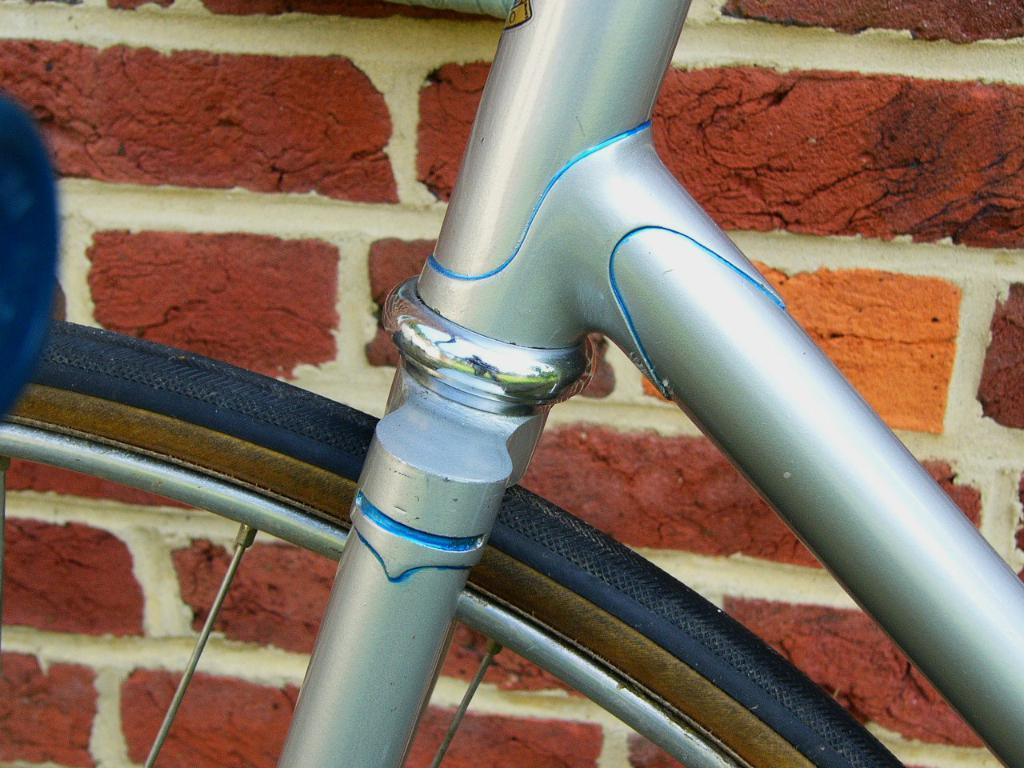What type of material is used for the rods in the image? The rods in the image are made of metal. What other object can be seen in the image besides the metal rods? There is a bicycle wheel in the image. What type of sail can be seen on the bicycle wheel in the image? There is no sail present on the bicycle wheel in the image. 